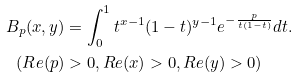Convert formula to latex. <formula><loc_0><loc_0><loc_500><loc_500>B _ { p } ( x , y ) & = \int _ { 0 } ^ { 1 } t ^ { x - 1 } ( 1 - t ) ^ { y - 1 } e ^ { - \frac { p } { t ( 1 - t ) } } d t . \\ ( R e ( p ) & > 0 , R e ( x ) > 0 , R e ( y ) > 0 )</formula> 